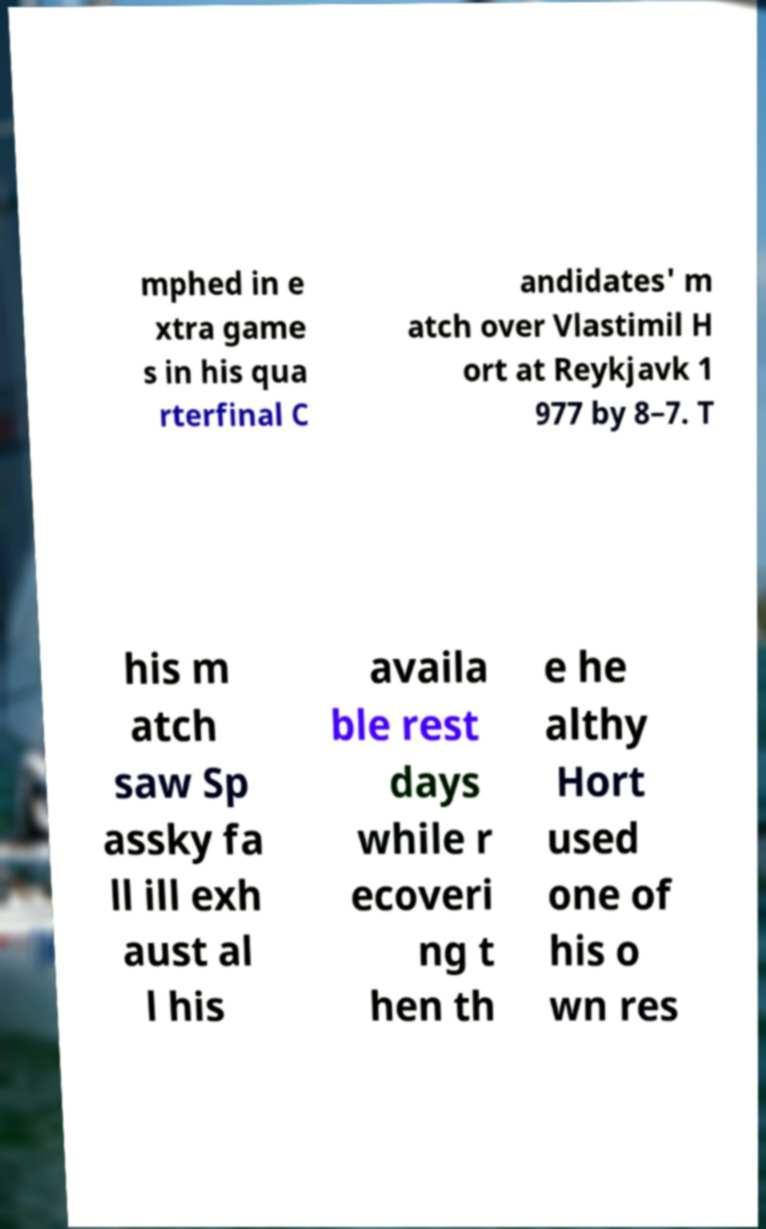There's text embedded in this image that I need extracted. Can you transcribe it verbatim? mphed in e xtra game s in his qua rterfinal C andidates' m atch over Vlastimil H ort at Reykjavk 1 977 by 8–7. T his m atch saw Sp assky fa ll ill exh aust al l his availa ble rest days while r ecoveri ng t hen th e he althy Hort used one of his o wn res 